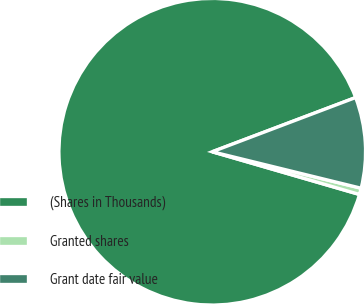Convert chart to OTSL. <chart><loc_0><loc_0><loc_500><loc_500><pie_chart><fcel>(Shares in Thousands)<fcel>Granted shares<fcel>Grant date fair value<nl><fcel>89.76%<fcel>0.67%<fcel>9.58%<nl></chart> 